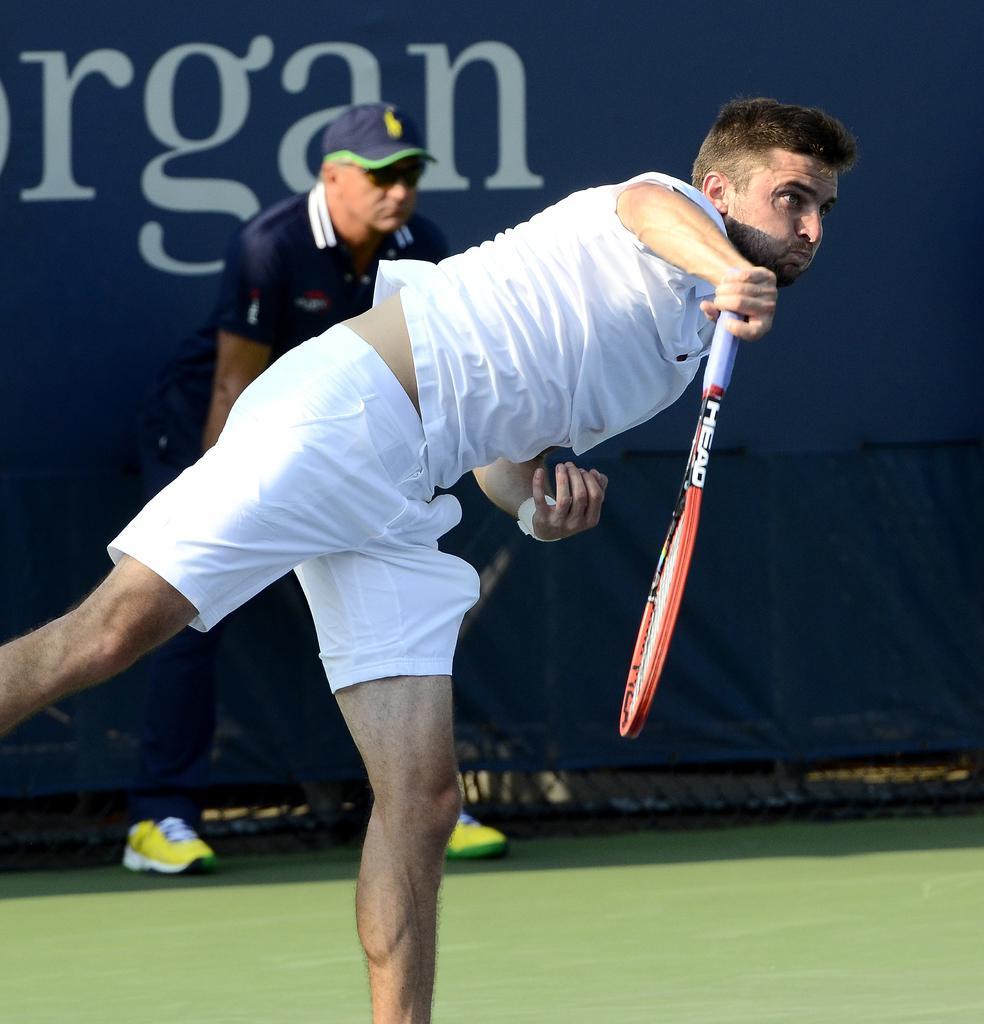How would you summarize this image in a sentence or two? In this image we can see this person wearing white dress is holding a racket in his hands and standing in the court. In the background, we can see this person is standing near the blue color board. 